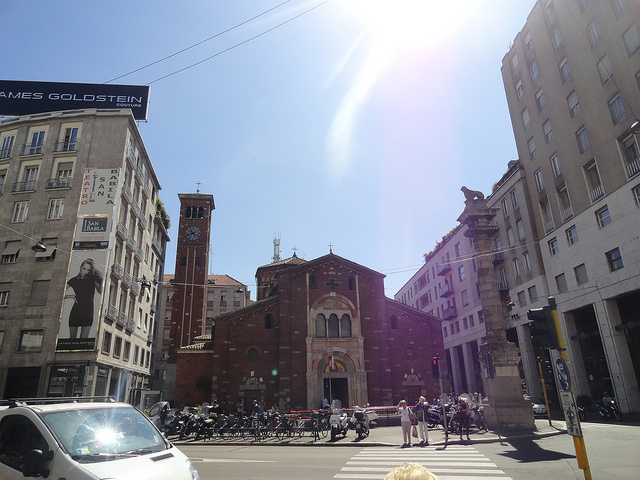Can you tell me more about the history of the building seen straight ahead? The building you're looking at is the Basilica of San Lorenzo Maggiore, one of the oldest churches in Milan. It dates back to the late Roman Empire, around the 4th century, making it a prominent historical site. Initially, it was built along with a series of chapels and other religious structures, forming a complex anticipated during the rise of Christianity in the Roman Empire. What is unique about its architecture? The architecture of San Lorenzo Maggiore is notable for its adoption of a circular or octagonal basis, which was quite unusual for the time. It features a central dome and multiple chapels surrounding it, employing a mix of Roman and later medieval elements. The church is also famous for the use of ancient columns known as the Colonne di San Lorenzo, which are Roman ruins placed directly in front of it. 